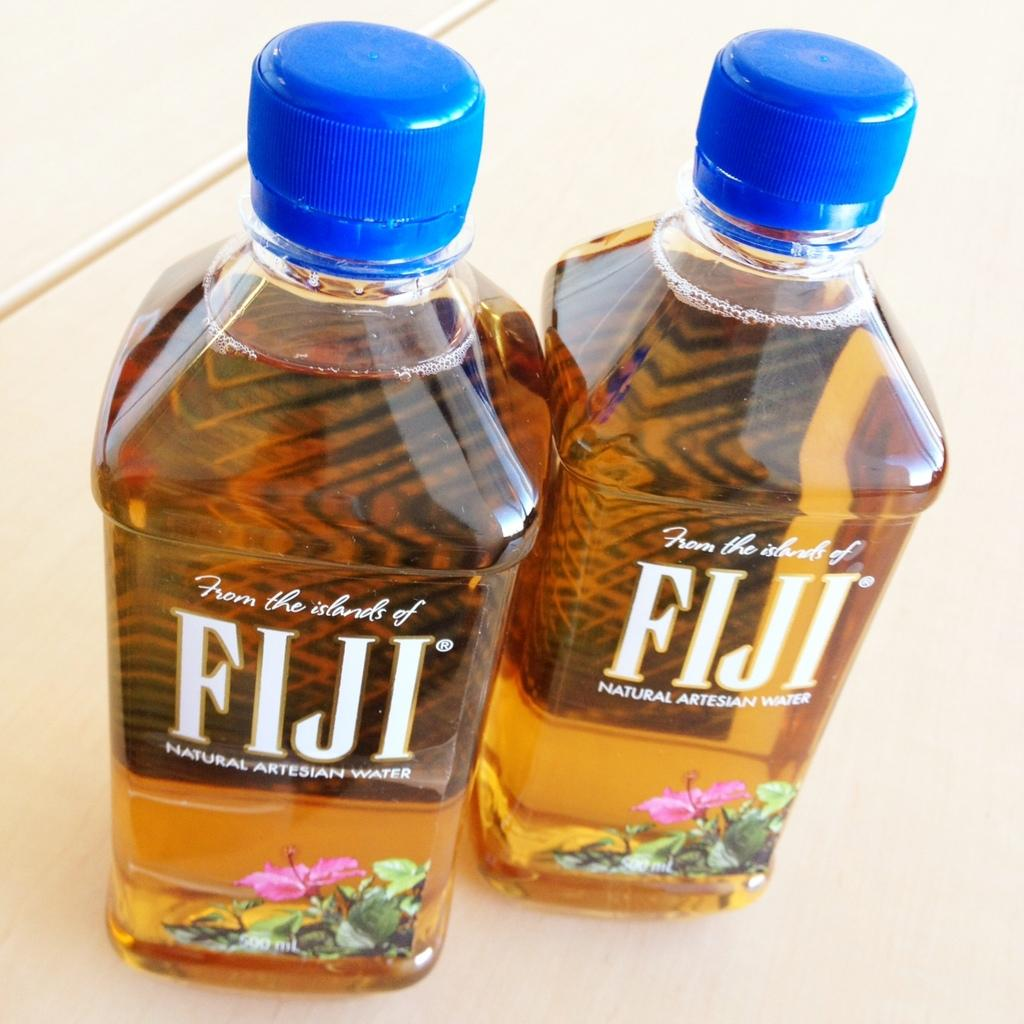How many water bottles are visible in the image? There are two water bottles in the image. Can you see an argument taking place between the water bottles in the image? There is no argument present in the image, as water bottles are inanimate objects and cannot engage in arguments. 